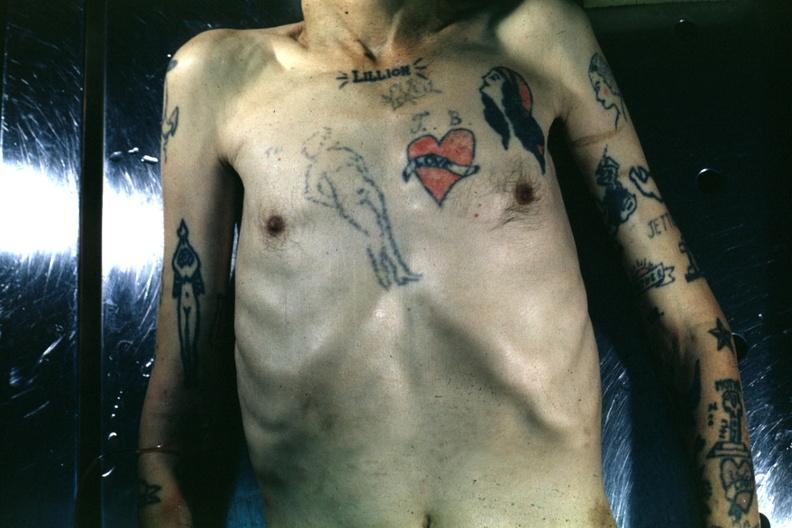what does this image show?
Answer the question using a single word or phrase. Upper portion of body with many tattoos 